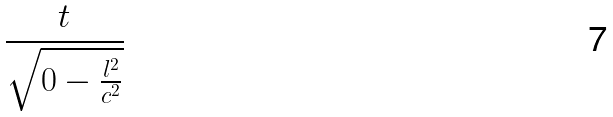Convert formula to latex. <formula><loc_0><loc_0><loc_500><loc_500>\frac { t } { \sqrt { 0 - \frac { l ^ { 2 } } { c ^ { 2 } } } }</formula> 